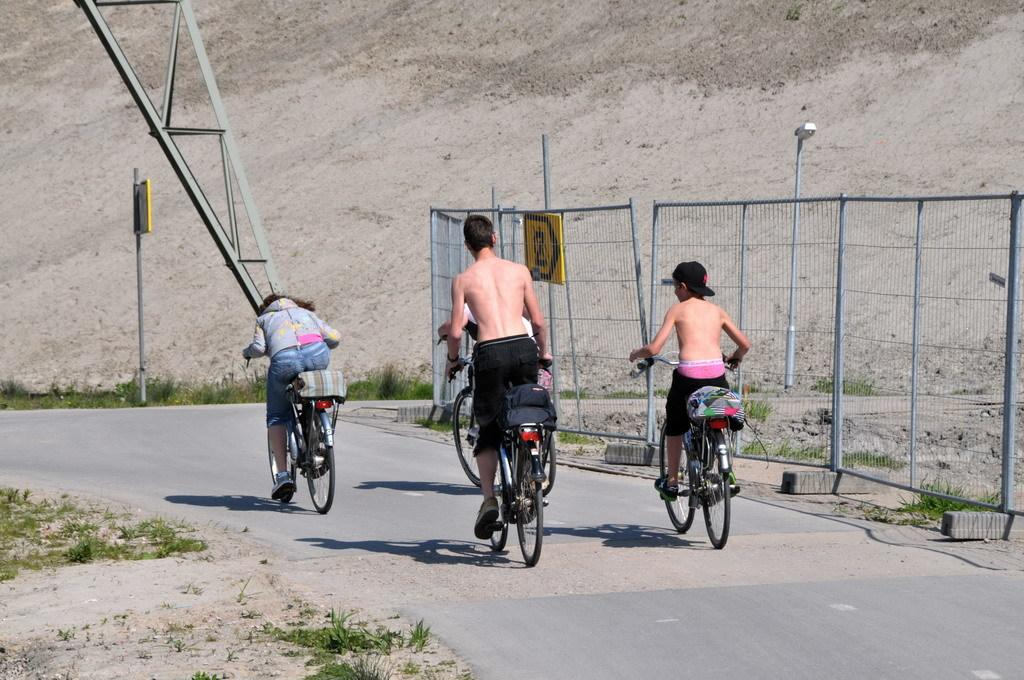What are the people in the image doing? The people in the image are riding bicycles. What can be seen in the background of the image? In the background, there is a fence, sign boards on poles, a light pole, a metal frame, a group of plants, and a hill. How many people are riding bicycles in the image? The number of people riding bicycles cannot be determined from the image. What is the amount of wealth displayed by the people in the image? There is no indication of wealth in the image, as it features people riding bicycles and various background elements. 